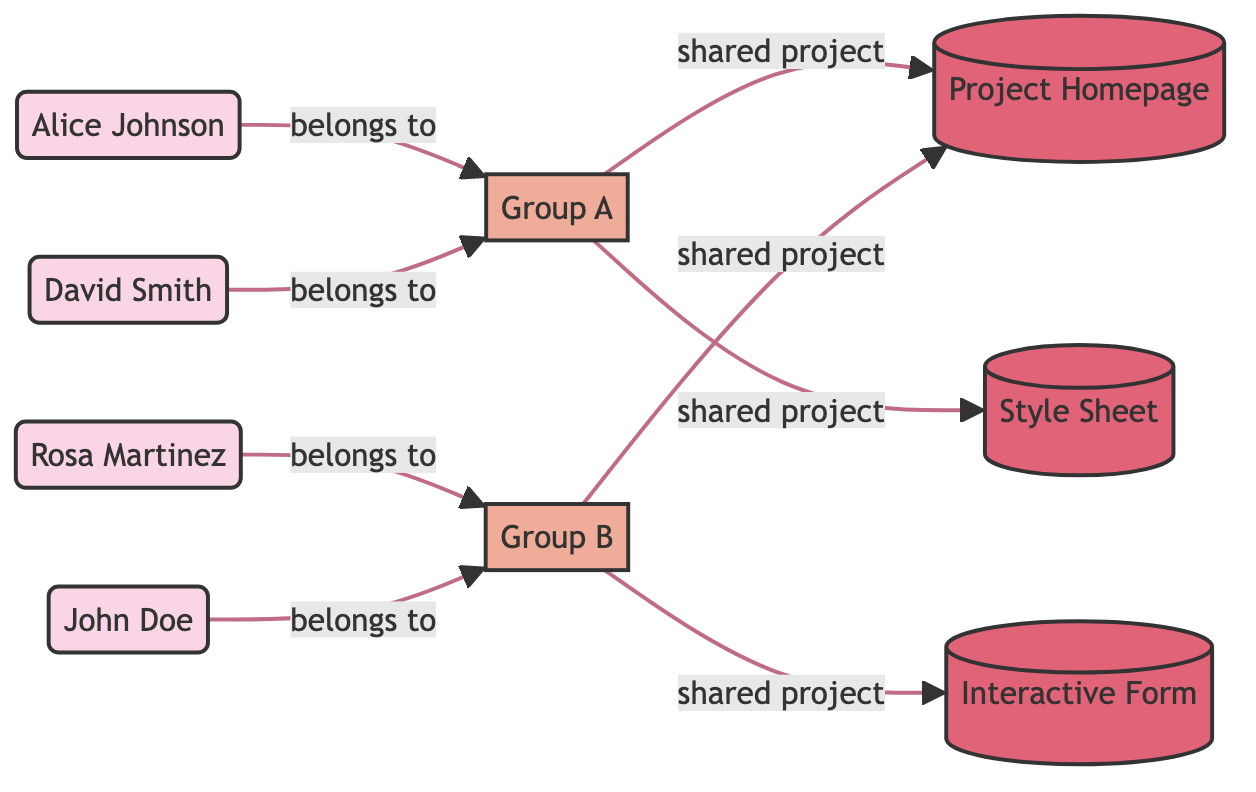What is the total number of nodes in the diagram? The nodes in the diagram include four students, two groups, and three HTML projects. Adding these together gives a total of 9 nodes (4 students + 2 groups + 3 projects = 9).
Answer: 9 How many students belong to Group A? From the diagram, Alice Johnson and David Smith are the two students connected to Group A. Therefore, there are 2 students belonging to Group A.
Answer: 2 Which project is shared by Group A? The edges show that both the Project Homepage and Style Sheet are shared by Group A. However, since the question asks for one project, we can identify that Project Homepage is the first project listed.
Answer: Project Homepage Who does Rosa Martinez belong to? The diagram shows an edge from Rosa Martinez to Group B, indicating that she belongs to Group B. Therefore, the answer is Group B.
Answer: Group B How many shared projects does Group B have? Looking at the connections, Group B shares two projects: Project Homepage and Interactive Form. So, the total number of shared projects by Group B is 2.
Answer: 2 Which students are part of the same group? From the diagram, Alice Johnson and David Smith are in Group A, while Rosa Martinez and John Doe are in Group B. Therefore, Alice Johnson and David Smith are part of the same group, and Rosa Martinez and John Doe are part of another.
Answer: Alice Johnson, David Smith; Rosa Martinez, John Doe Is the Interactive Form shared by Group A? Observing the edges, we can see that the Interactive Form is only connected to Group B. This indicates that it is not shared by Group A.
Answer: No How many edges are linked to Group A? Analyzing the diagram, Group A has two edges leading to the shared projects: Project Homepage and Style Sheet. Thus, the total number of edges linked to Group A is 2.
Answer: 2 Which project is shared only by Group B? The diagram shows that Interactive Form is exclusively shared by Group B, as there are no connections to this project from Group A. Consequently, the only project shared by Group B is the Interactive Form.
Answer: Interactive Form 